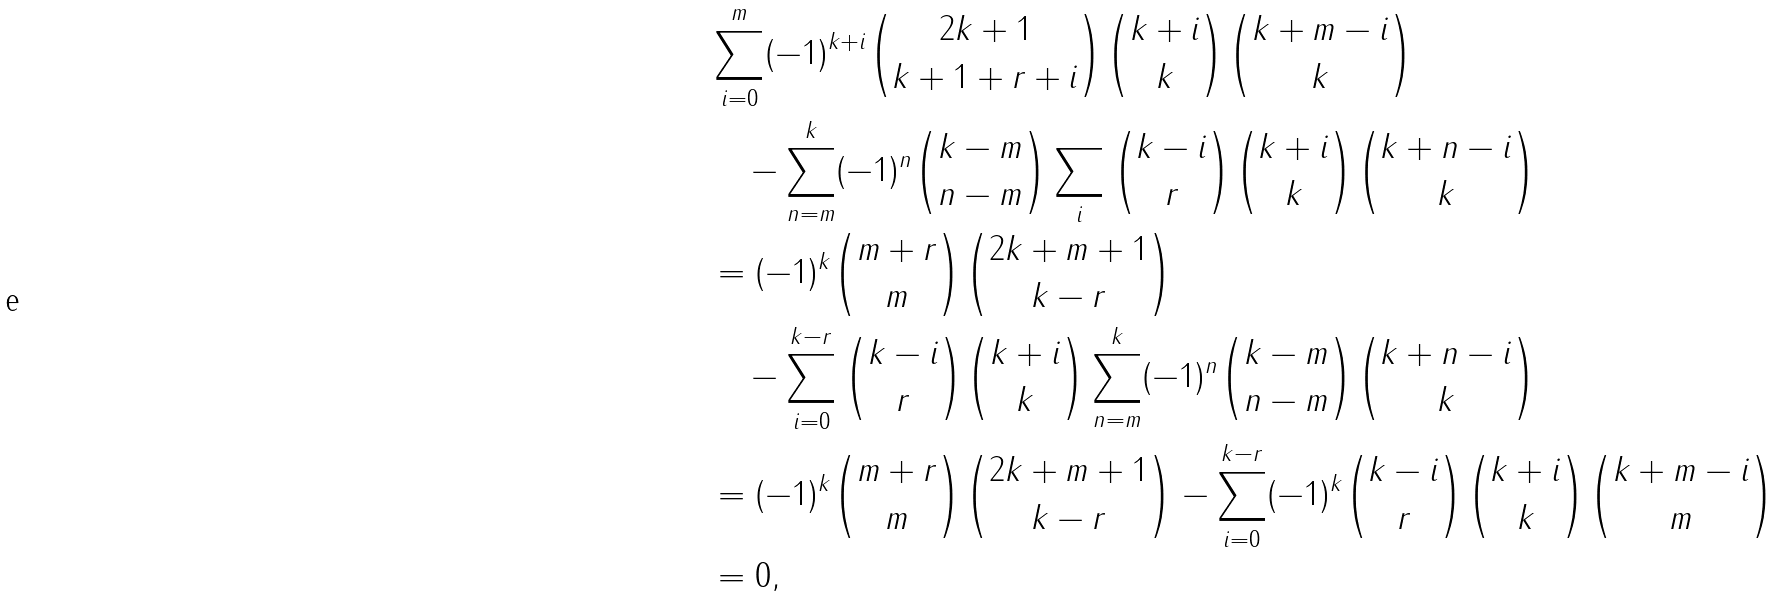<formula> <loc_0><loc_0><loc_500><loc_500>& \sum _ { i = 0 } ^ { m } ( - 1 ) ^ { k + i } \binom { 2 k + 1 } { k + 1 + r + i } \binom { k + i } { k } \binom { k + m - i } { k } \\ & \quad - \sum _ { n = m } ^ { k } ( - 1 ) ^ { n } \binom { k - m } { n - m } \sum _ { i } \binom { k - i } { r } \binom { k + i } { k } \binom { k + n - i } { k } \\ & = ( - 1 ) ^ { k } \binom { m + r } { m } \binom { 2 k + m + 1 } { k - r } \\ & \quad - \sum _ { i = 0 } ^ { k - r } \binom { k - i } { r } \binom { k + i } { k } \sum _ { n = m } ^ { k } ( - 1 ) ^ { n } \binom { k - m } { n - m } \binom { k + n - i } { k } \\ & = ( - 1 ) ^ { k } \binom { m + r } { m } \binom { 2 k + m + 1 } { k - r } - \sum _ { i = 0 } ^ { k - r } ( - 1 ) ^ { k } \binom { k - i } { r } \binom { k + i } { k } \binom { k + m - i } { m } \\ & = 0 ,</formula> 